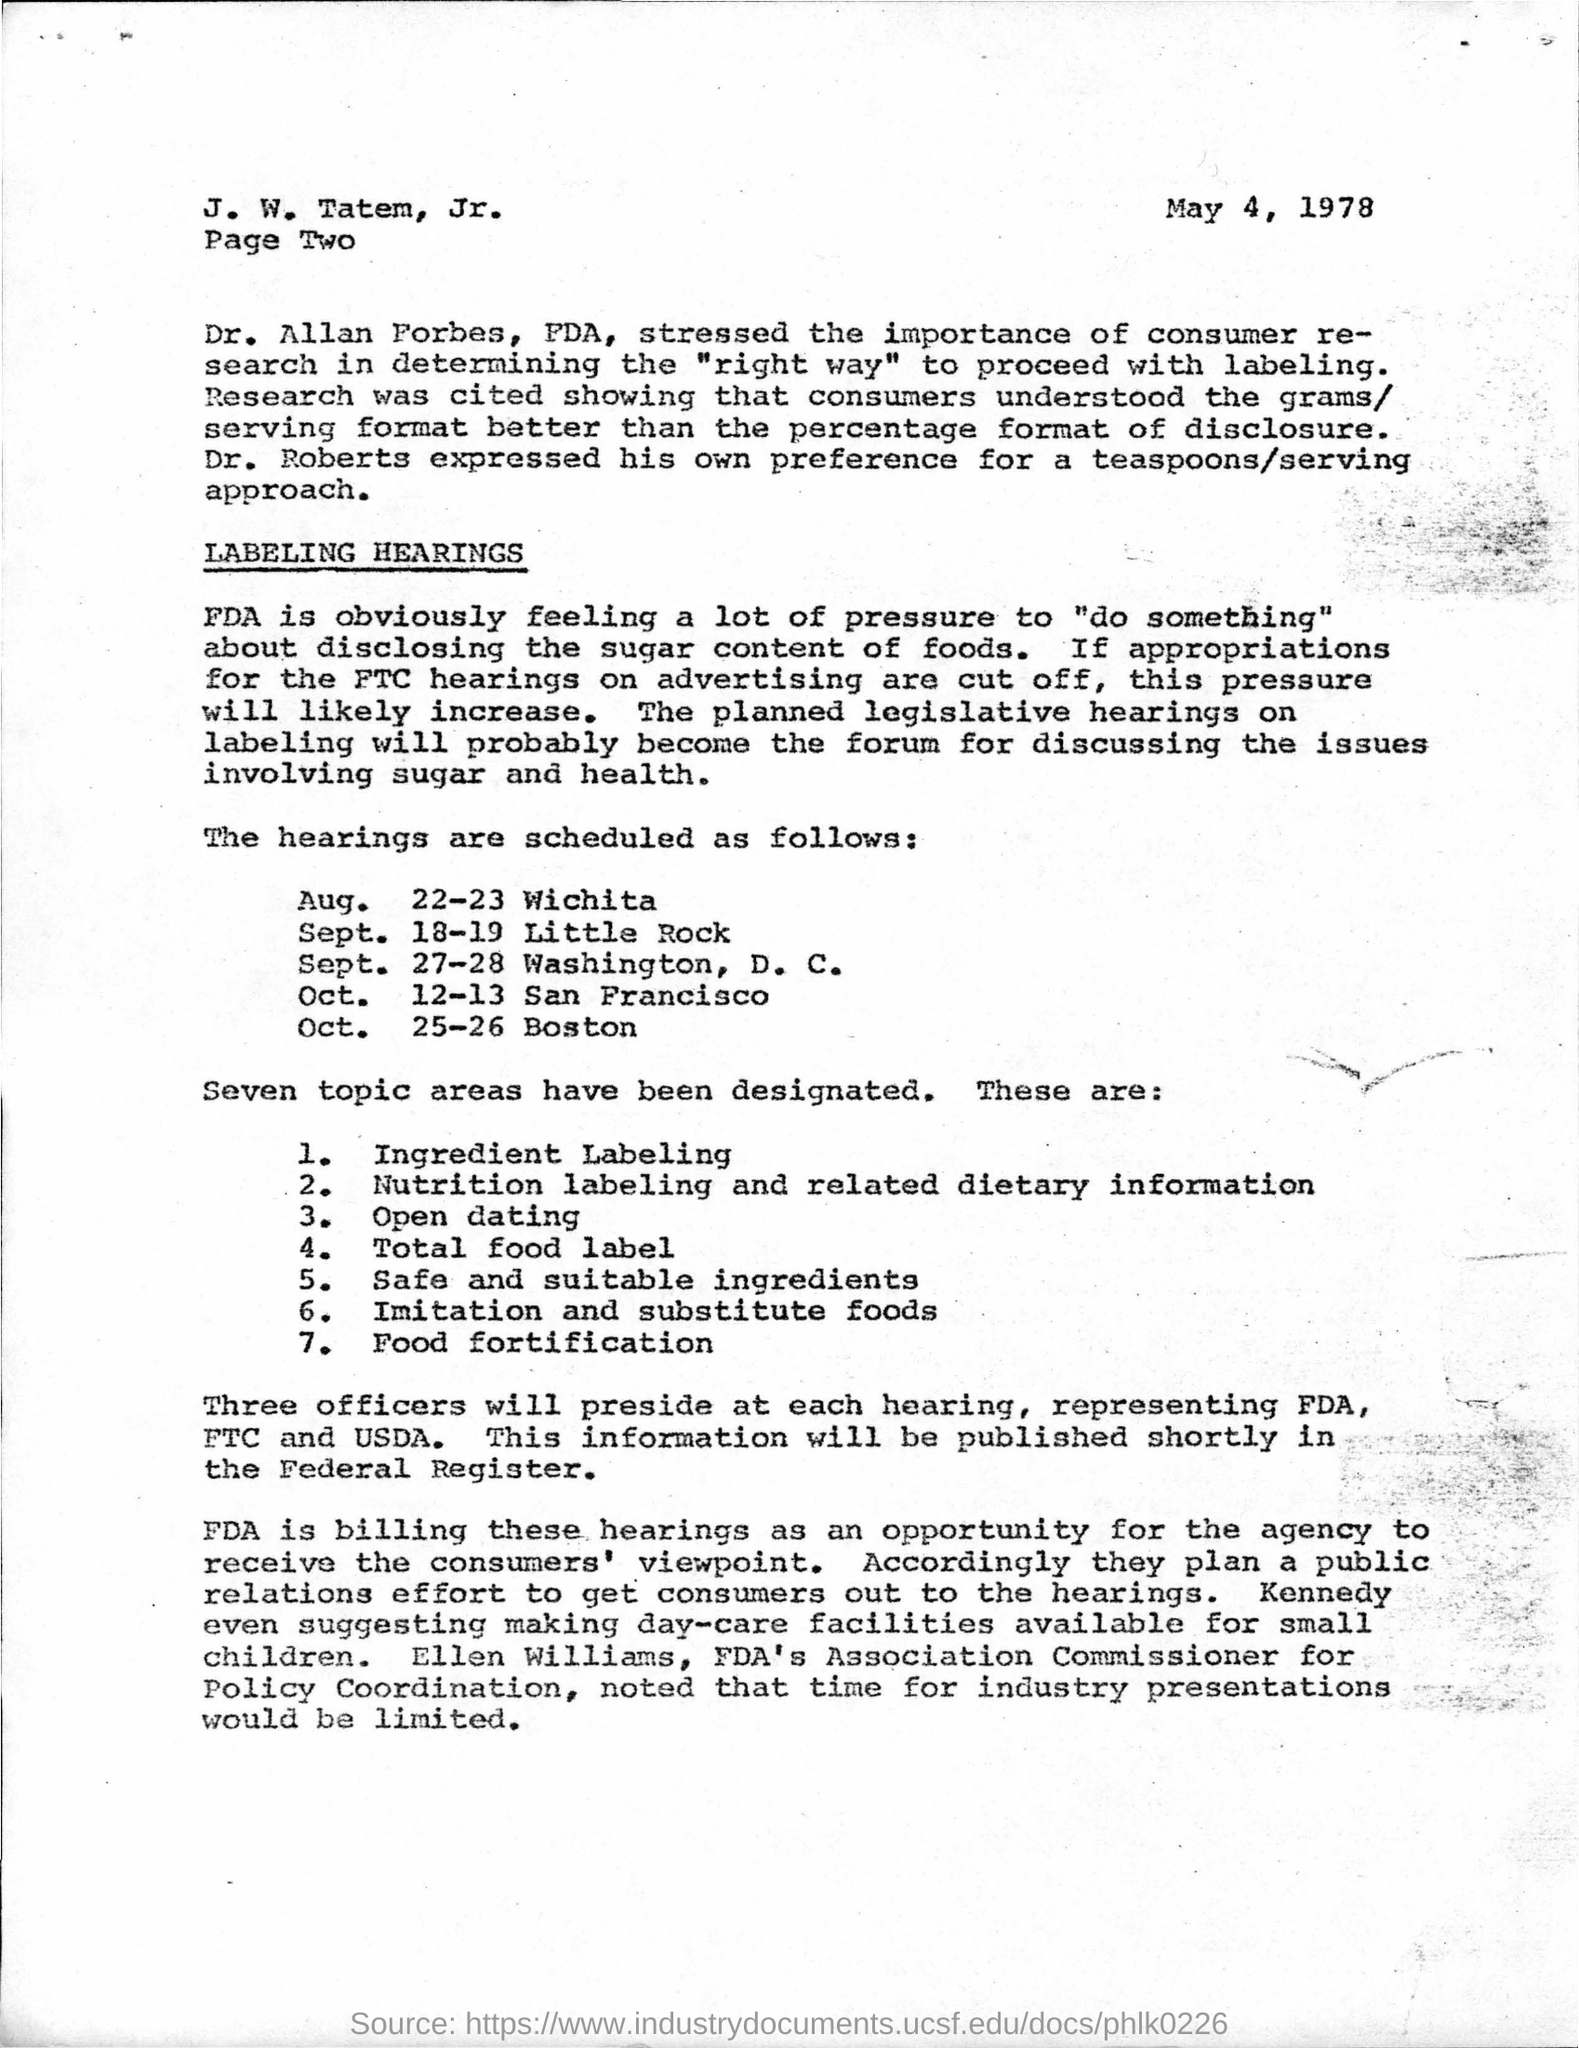Point out several critical features in this image. The hearing for Wichita is scheduled to take place on August 22nd and 23rd. The hearing is scheduled for October 12th and 13th in San Francisco. 